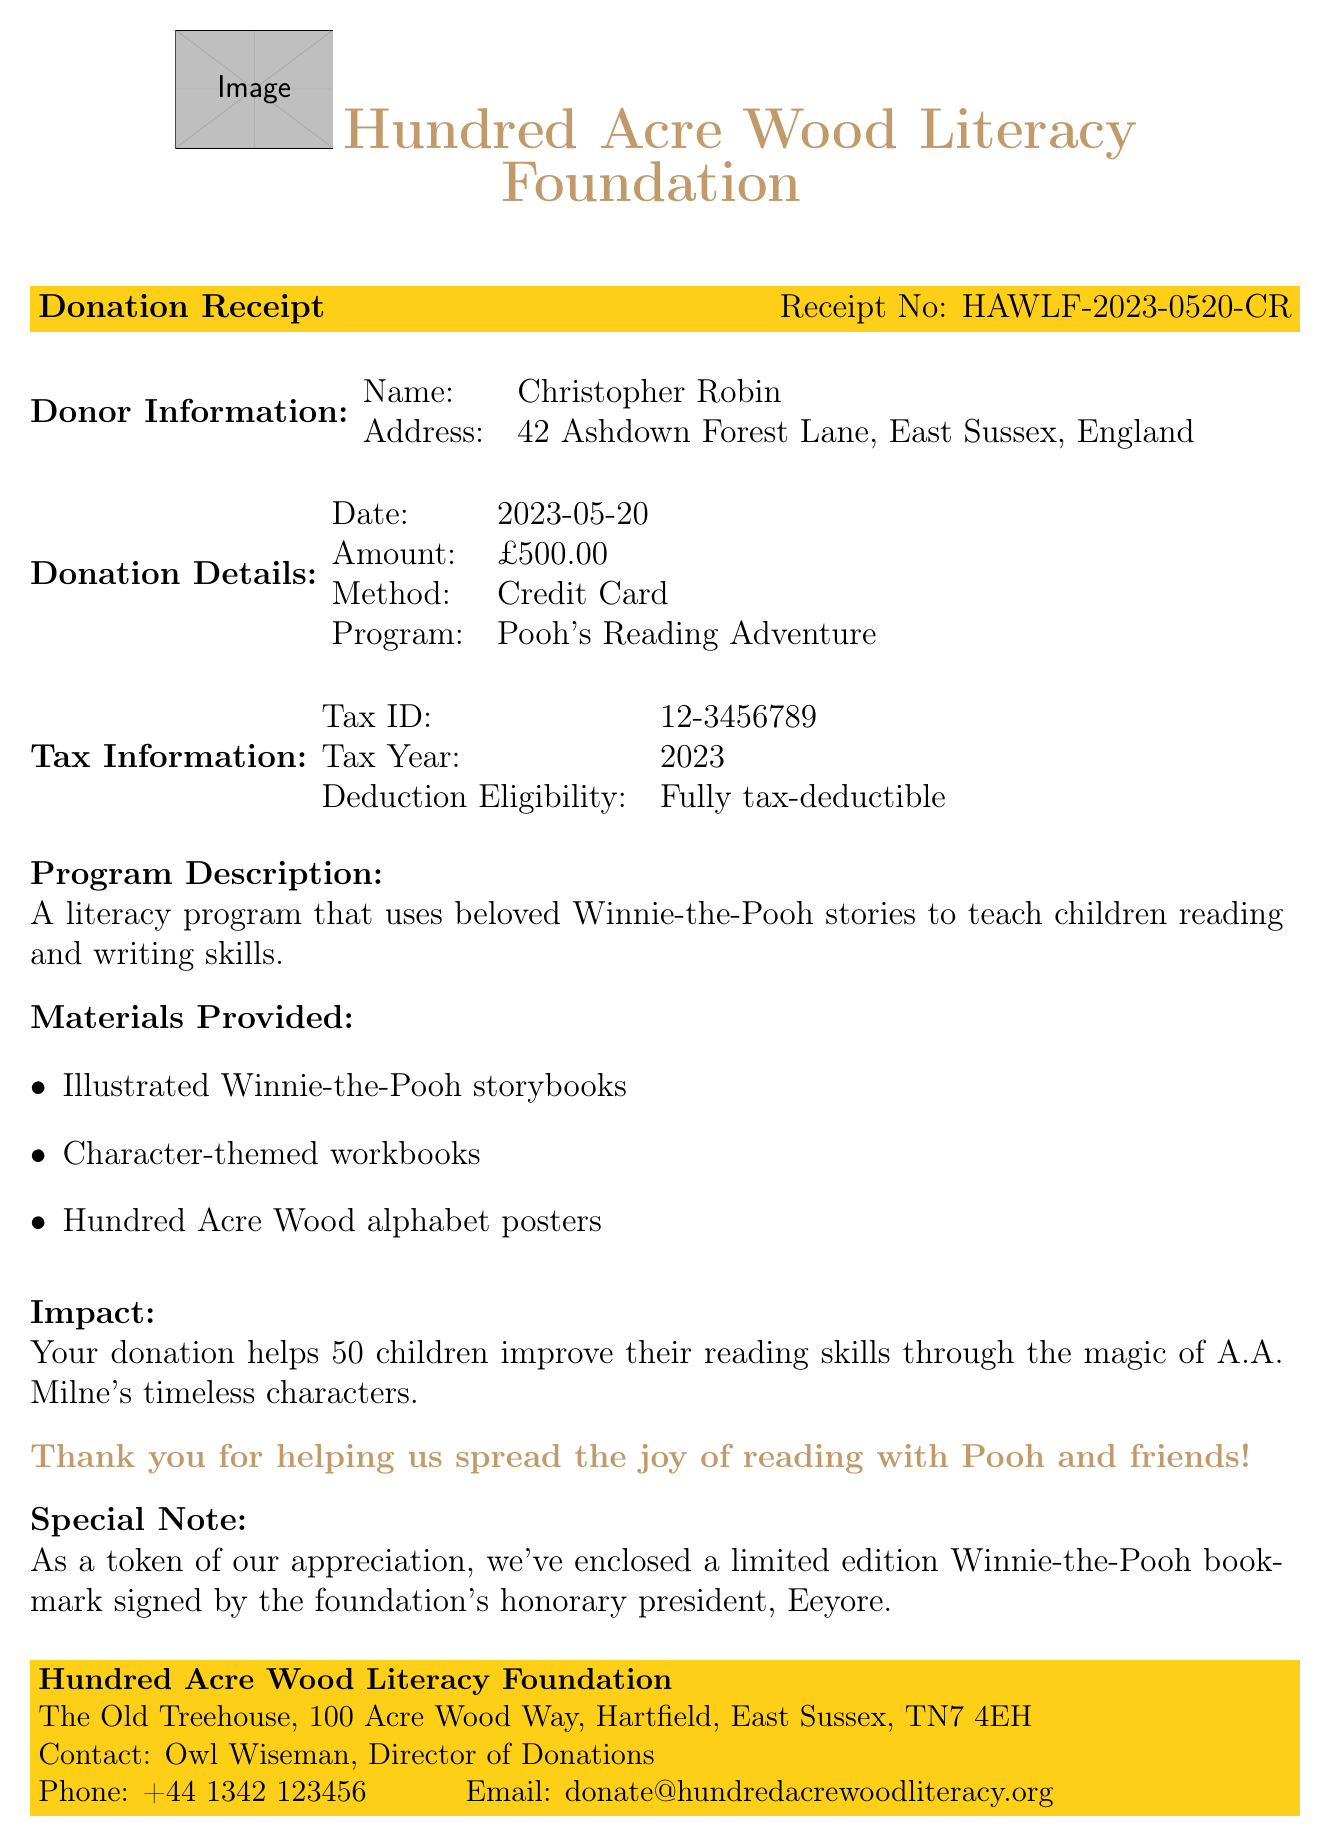What is the name of the organization? The name of the organization is identified in the document header.
Answer: Hundred Acre Wood Literacy Foundation Who is the donor? The document specifies the recipient of the donation.
Answer: Christopher Robin What is the donation amount? The donation amount is explicitly stated in the donation details section.
Answer: £500.00 What is the donation date? The donation date is provided under the donation details section.
Answer: 2023-05-20 What method was used to make the donation? The method of donation is outlined in the donation details section.
Answer: Credit Card What is the tax ID number? The tax ID number is mentioned in the tax information section of the document.
Answer: 12-3456789 How many children benefit from the donation? The impact statement explains the number of children helped by the donation.
Answer: 50 children Is the donation tax-deductible? The eligibility for tax deduction is stated under the tax information section.
Answer: Fully tax-deductible What program does the donation support? The program being supported is described in the donation details.
Answer: Pooh's Reading Adventure 